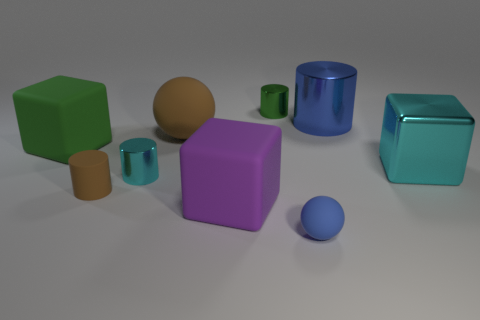What number of matte things are tiny purple objects or big blue cylinders?
Provide a short and direct response. 0. The large blue thing that is made of the same material as the big cyan block is what shape?
Make the answer very short. Cylinder. How many big blue things have the same shape as the big cyan metal object?
Keep it short and to the point. 0. Does the tiny green metallic object behind the big cyan shiny thing have the same shape as the brown thing in front of the large shiny cube?
Your response must be concise. Yes. How many objects are either matte cylinders or blue objects in front of the blue metallic object?
Your answer should be very brief. 2. The metal object that is the same color as the tiny rubber sphere is what shape?
Provide a succinct answer. Cylinder. How many other metal cubes have the same size as the purple block?
Provide a succinct answer. 1. What number of red things are either small objects or large shiny cylinders?
Offer a terse response. 0. The cyan metal object behind the cyan object left of the small sphere is what shape?
Make the answer very short. Cube. There is another metallic object that is the same size as the green metal thing; what shape is it?
Your response must be concise. Cylinder. 